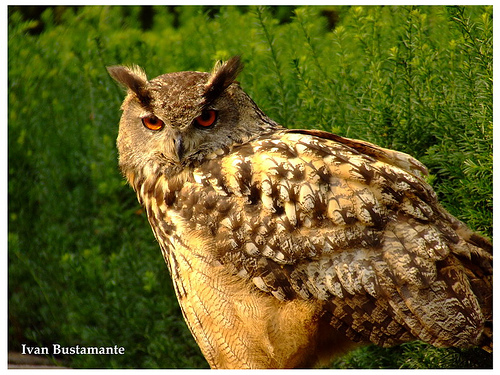<image>What kind of Owl is this? I don't know exactly what kind of Owl this is. It could be a barn owl or a horned owl. What kind of Owl is this? I don't know what kind of owl this is. It can be either a barn owl or a horned owl. 